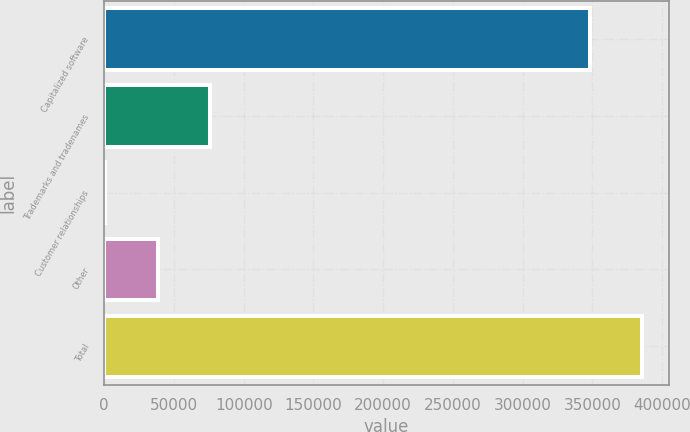Convert chart to OTSL. <chart><loc_0><loc_0><loc_500><loc_500><bar_chart><fcel>Capitalized software<fcel>Trademarks and tradenames<fcel>Customer relationships<fcel>Other<fcel>Total<nl><fcel>348022<fcel>76010<fcel>620<fcel>38315<fcel>385717<nl></chart> 